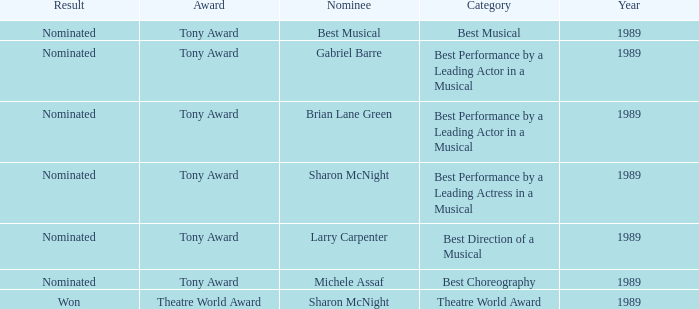What year was michele assaf nominated 1989.0. 